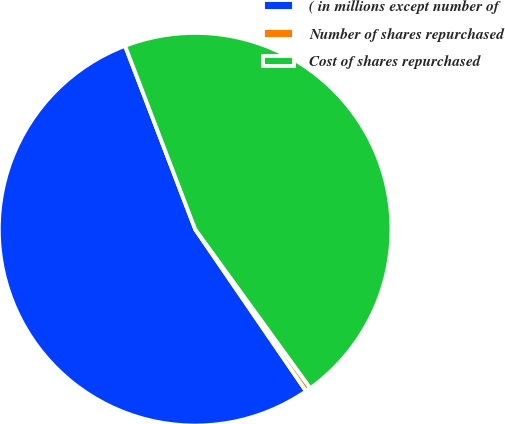Convert chart. <chart><loc_0><loc_0><loc_500><loc_500><pie_chart><fcel>( in millions except number of<fcel>Number of shares repurchased<fcel>Cost of shares repurchased<nl><fcel>53.74%<fcel>0.42%<fcel>45.83%<nl></chart> 